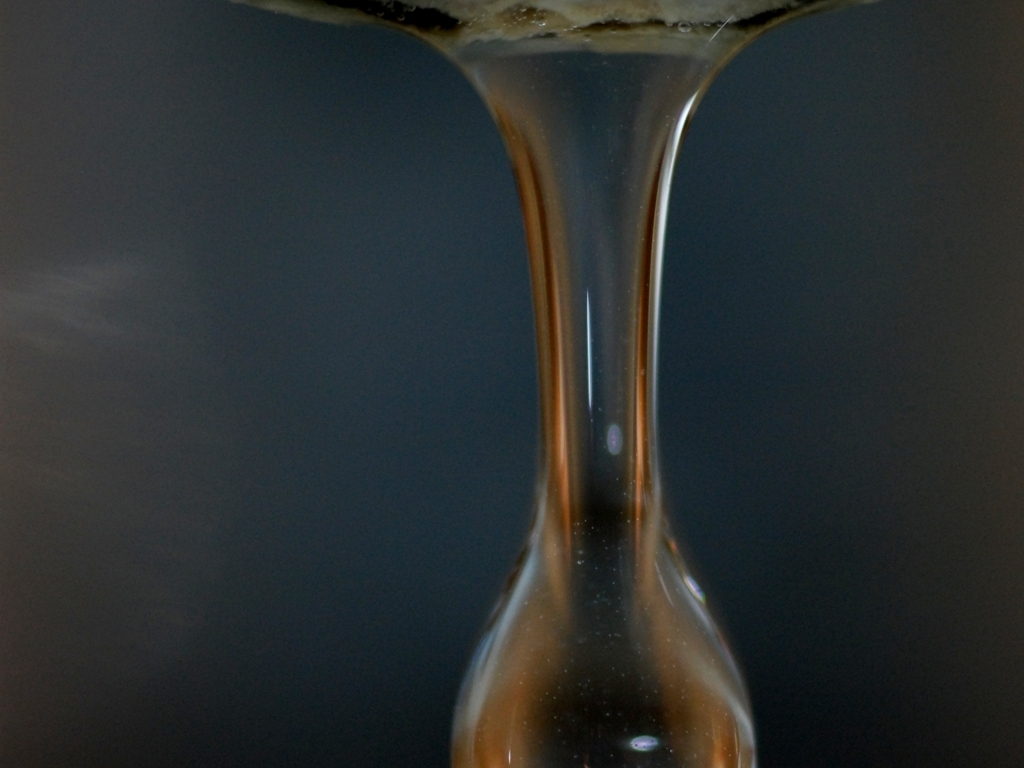What is happening in this image? The image captures a moment where a liquid is forming a droplet, a process known as dripping. The shallow depth of field focuses on the droplet, creating a smooth background and a sense of motion. 